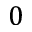<formula> <loc_0><loc_0><loc_500><loc_500>0</formula> 